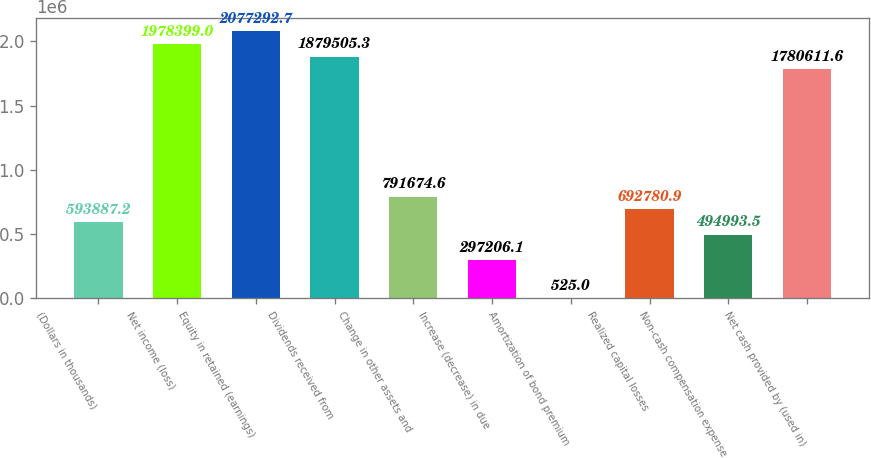<chart> <loc_0><loc_0><loc_500><loc_500><bar_chart><fcel>(Dollars in thousands)<fcel>Net income (loss)<fcel>Equity in retained (earnings)<fcel>Dividends received from<fcel>Change in other assets and<fcel>Increase (decrease) in due<fcel>Amortization of bond premium<fcel>Realized capital losses<fcel>Non-cash compensation expense<fcel>Net cash provided by (used in)<nl><fcel>593887<fcel>1.9784e+06<fcel>2.07729e+06<fcel>1.87951e+06<fcel>791675<fcel>297206<fcel>525<fcel>692781<fcel>494994<fcel>1.78061e+06<nl></chart> 